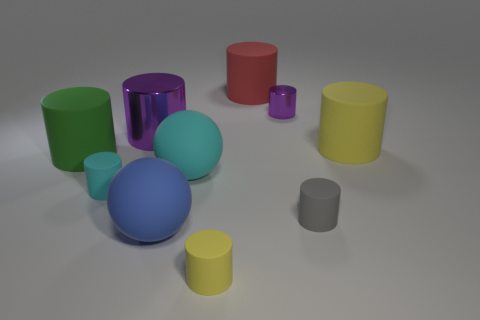Subtract all red cylinders. How many cylinders are left? 7 Subtract all yellow rubber cylinders. How many cylinders are left? 6 Subtract all yellow cylinders. Subtract all purple spheres. How many cylinders are left? 6 Subtract all balls. How many objects are left? 8 Add 1 tiny purple cylinders. How many tiny purple cylinders exist? 2 Subtract 0 red blocks. How many objects are left? 10 Subtract all red things. Subtract all purple cylinders. How many objects are left? 7 Add 1 small yellow things. How many small yellow things are left? 2 